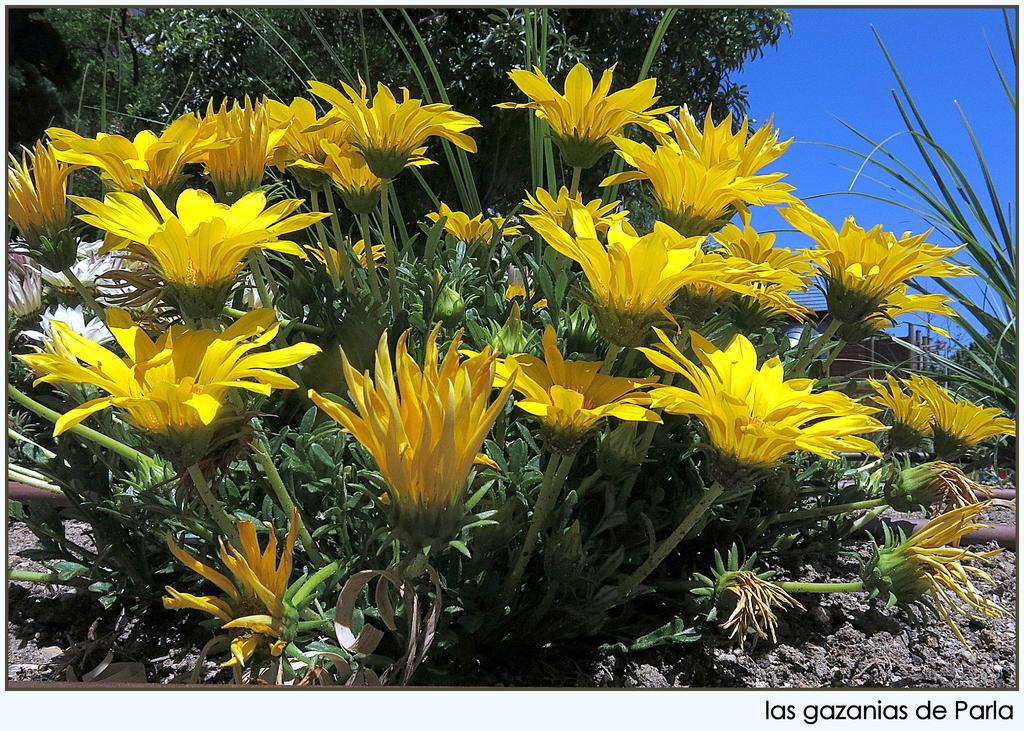Describe this image in one or two sentences. In this image in front there is a plant with the yellow flowers on it. On the backside there are trees and sky. At the bottom there is mud. 